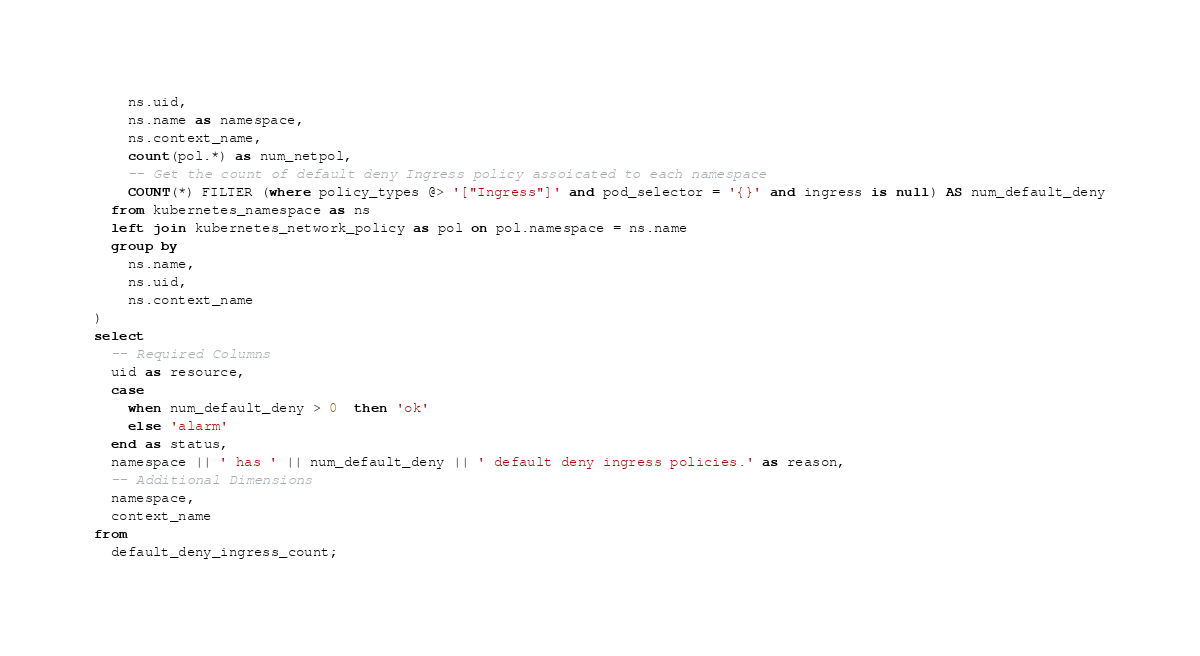<code> <loc_0><loc_0><loc_500><loc_500><_SQL_>    ns.uid,
    ns.name as namespace,
    ns.context_name,
    count(pol.*) as num_netpol,
    -- Get the count of default deny Ingress policy assoicated to each namespace
    COUNT(*) FILTER (where policy_types @> '["Ingress"]' and pod_selector = '{}' and ingress is null) AS num_default_deny
  from kubernetes_namespace as ns
  left join kubernetes_network_policy as pol on pol.namespace = ns.name
  group by
    ns.name,
    ns.uid,
    ns.context_name
)
select
  -- Required Columns
  uid as resource,
  case
    when num_default_deny > 0  then 'ok'
    else 'alarm'
  end as status,
  namespace || ' has ' || num_default_deny || ' default deny ingress policies.' as reason,
  -- Additional Dimensions
  namespace,
  context_name
from
  default_deny_ingress_count;</code> 